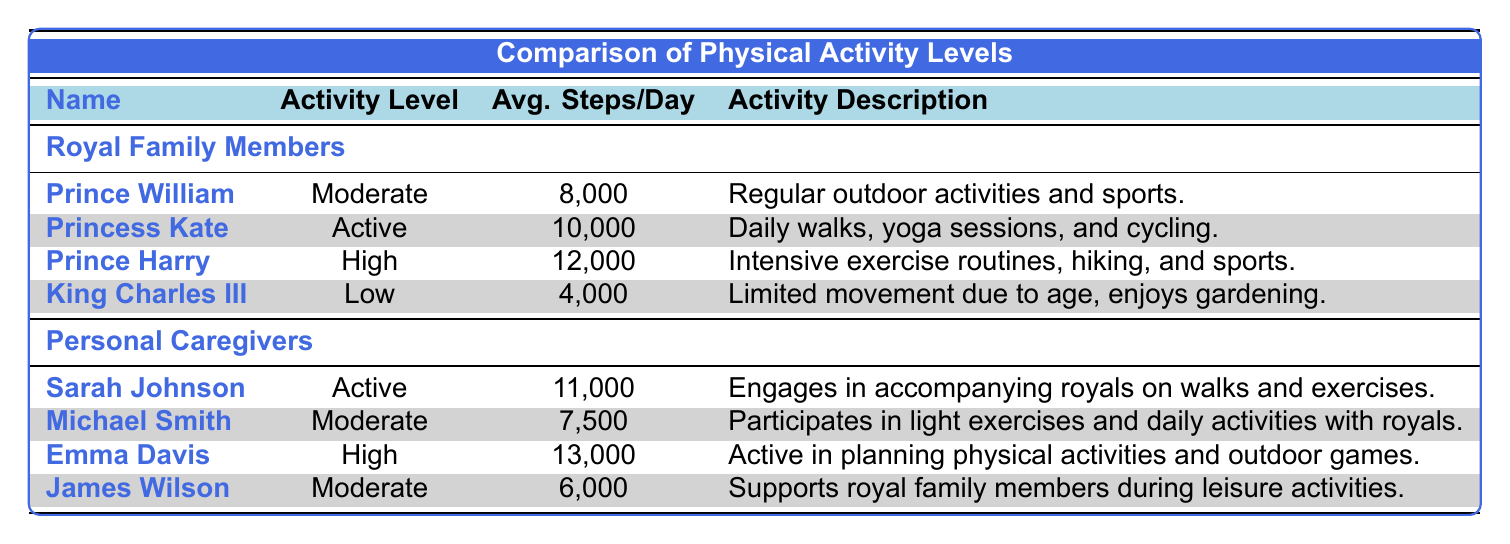What is the average number of steps per day for Prince Harry? According to the table, Prince Harry averages 12,000 steps per day.
Answer: 12,000 How many steps does King Charles III average compared to Princess Kate? King Charles III averages 4,000 steps per day and Princess Kate averages 10,000. The difference is 10,000 - 4,000 = 6,000 steps.
Answer: King Charles III averages 6,000 steps less Is Sarah Johnson’s activity level higher than that of Prince William? Sarah Johnson has an active activity level and Prince William has a moderate activity level. Yes, active is higher than moderate.
Answer: Yes What is the total average number of steps per day for all personal caregivers? The personal caregivers' average steps are 11,000 (Sarah Johnson) + 7,500 (Michael Smith) + 13,000 (Emma Davis) + 6,000 (James Wilson) = 37,500 steps. There are 4 caregivers, so the average is 37,500 / 4 = 9,375 steps per day.
Answer: 9,375 Who has the highest average steps per day among the royal family members? The table shows that Prince Harry has the highest average steps per day at 12,000.
Answer: Prince Harry Is Emma Davis's activity level higher than King Charles III’s? Emma Davis has a high activity level, while King Charles III has a low activity level. Yes, high is greater than low.
Answer: Yes What is the average number of steps taken by the royal family members? The average for royal family members is calculated as follows: (8,000 + 10,000 + 12,000 + 4,000) = 34,000 steps combined. There are 4 family members, so the average is 34,000 / 4 = 8,500 steps per day.
Answer: 8,500 How many more steps does Emma Davis take on average compared to Michael Smith? Emma Davis averages 13,000 steps, and Michael Smith averages 7,500 steps. The difference is 13,000 - 7,500 = 5,500 steps.
Answer: 5,500 Does James Wilson have a higher average number of steps than King Charles III? James Wilson averages 6,000 steps and King Charles III averages 4,000 steps. Yes, 6,000 is greater than 4,000.
Answer: Yes 